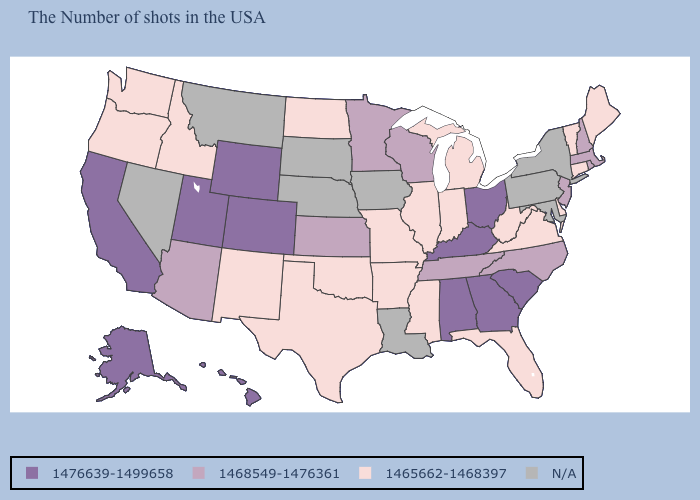Does the map have missing data?
Give a very brief answer. Yes. What is the lowest value in states that border Utah?
Answer briefly. 1465662-1468397. What is the value of California?
Be succinct. 1476639-1499658. What is the value of Connecticut?
Short answer required. 1465662-1468397. What is the highest value in the West ?
Be succinct. 1476639-1499658. What is the value of Rhode Island?
Short answer required. 1468549-1476361. What is the value of Virginia?
Quick response, please. 1465662-1468397. What is the value of Delaware?
Keep it brief. 1465662-1468397. Which states have the lowest value in the USA?
Answer briefly. Maine, Vermont, Connecticut, Delaware, Virginia, West Virginia, Florida, Michigan, Indiana, Illinois, Mississippi, Missouri, Arkansas, Oklahoma, Texas, North Dakota, New Mexico, Idaho, Washington, Oregon. Among the states that border Oklahoma , does Colorado have the lowest value?
Keep it brief. No. What is the value of Florida?
Be succinct. 1465662-1468397. What is the lowest value in the USA?
Short answer required. 1465662-1468397. Does the map have missing data?
Give a very brief answer. Yes. Which states have the lowest value in the South?
Write a very short answer. Delaware, Virginia, West Virginia, Florida, Mississippi, Arkansas, Oklahoma, Texas. 